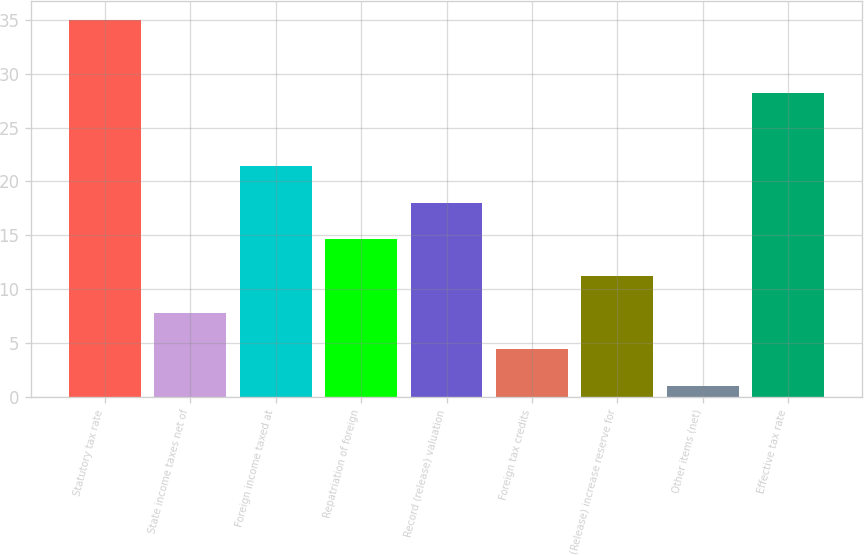Convert chart to OTSL. <chart><loc_0><loc_0><loc_500><loc_500><bar_chart><fcel>Statutory tax rate<fcel>State income taxes net of<fcel>Foreign income taxed at<fcel>Repatriation of foreign<fcel>Record (release) valuation<fcel>Foreign tax credits<fcel>(Release) increase reserve for<fcel>Other items (net)<fcel>Effective tax rate<nl><fcel>35<fcel>7.8<fcel>21.4<fcel>14.6<fcel>18<fcel>4.4<fcel>11.2<fcel>1<fcel>28.2<nl></chart> 